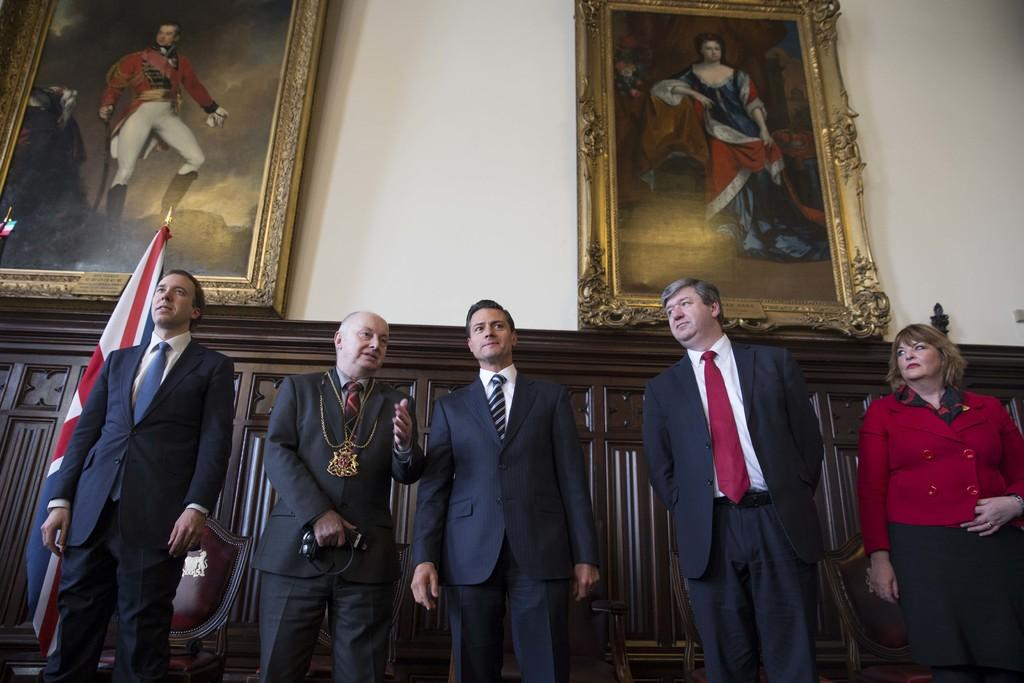What is the main subject of the image? The main subject of the image is a group of persons in the center of the image. What can be seen in the background of the image? In the background of the image, there is a flag, photo frames, and a wall. What type of acoustics can be heard from the wing in the image? There is no wing present in the image, so it is not possible to determine the acoustics. 